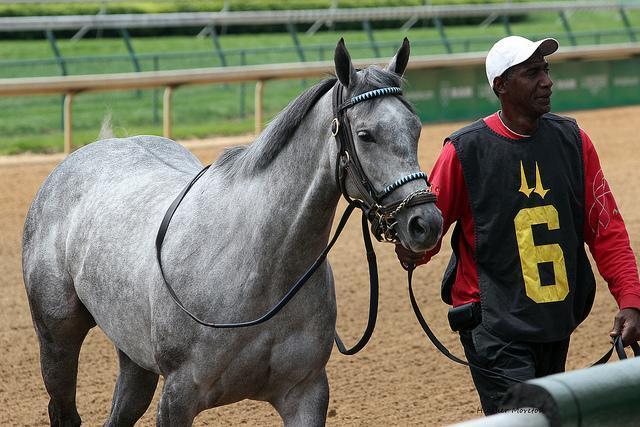How many horses can be seen?
Give a very brief answer. 1. How many people are visible?
Give a very brief answer. 1. 